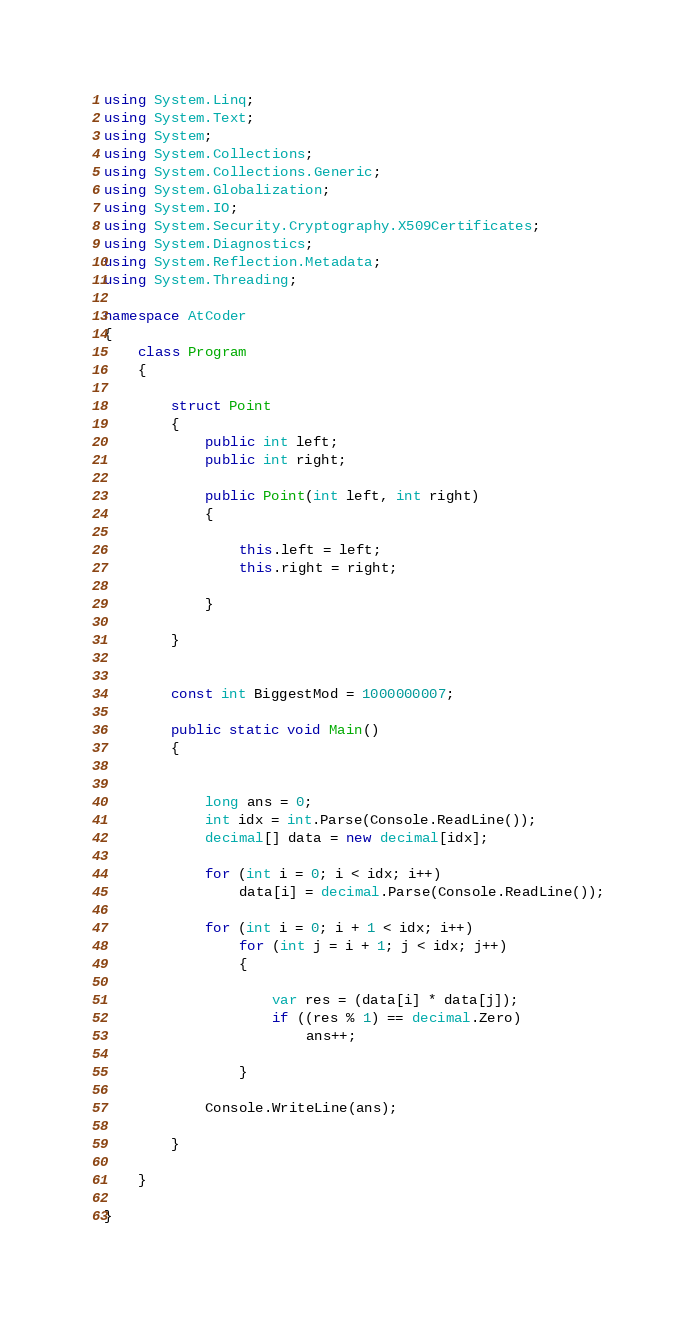<code> <loc_0><loc_0><loc_500><loc_500><_C#_>using System.Linq;
using System.Text;
using System;
using System.Collections;
using System.Collections.Generic;
using System.Globalization;
using System.IO;
using System.Security.Cryptography.X509Certificates;
using System.Diagnostics;
using System.Reflection.Metadata;
using System.Threading;

namespace AtCoder
{
    class Program
    {

        struct Point
        {
            public int left;
            public int right;

            public Point(int left, int right)
            {

                this.left = left;
                this.right = right;

            }

        }


        const int BiggestMod = 1000000007;

        public static void Main()
        {

            
            long ans = 0;
            int idx = int.Parse(Console.ReadLine());
            decimal[] data = new decimal[idx];

            for (int i = 0; i < idx; i++)
                data[i] = decimal.Parse(Console.ReadLine());

            for (int i = 0; i + 1 < idx; i++)
                for (int j = i + 1; j < idx; j++)
                {

                    var res = (data[i] * data[j]);
                    if ((res % 1) == decimal.Zero)
                        ans++;

                }

            Console.WriteLine(ans);

        }

    }

}</code> 